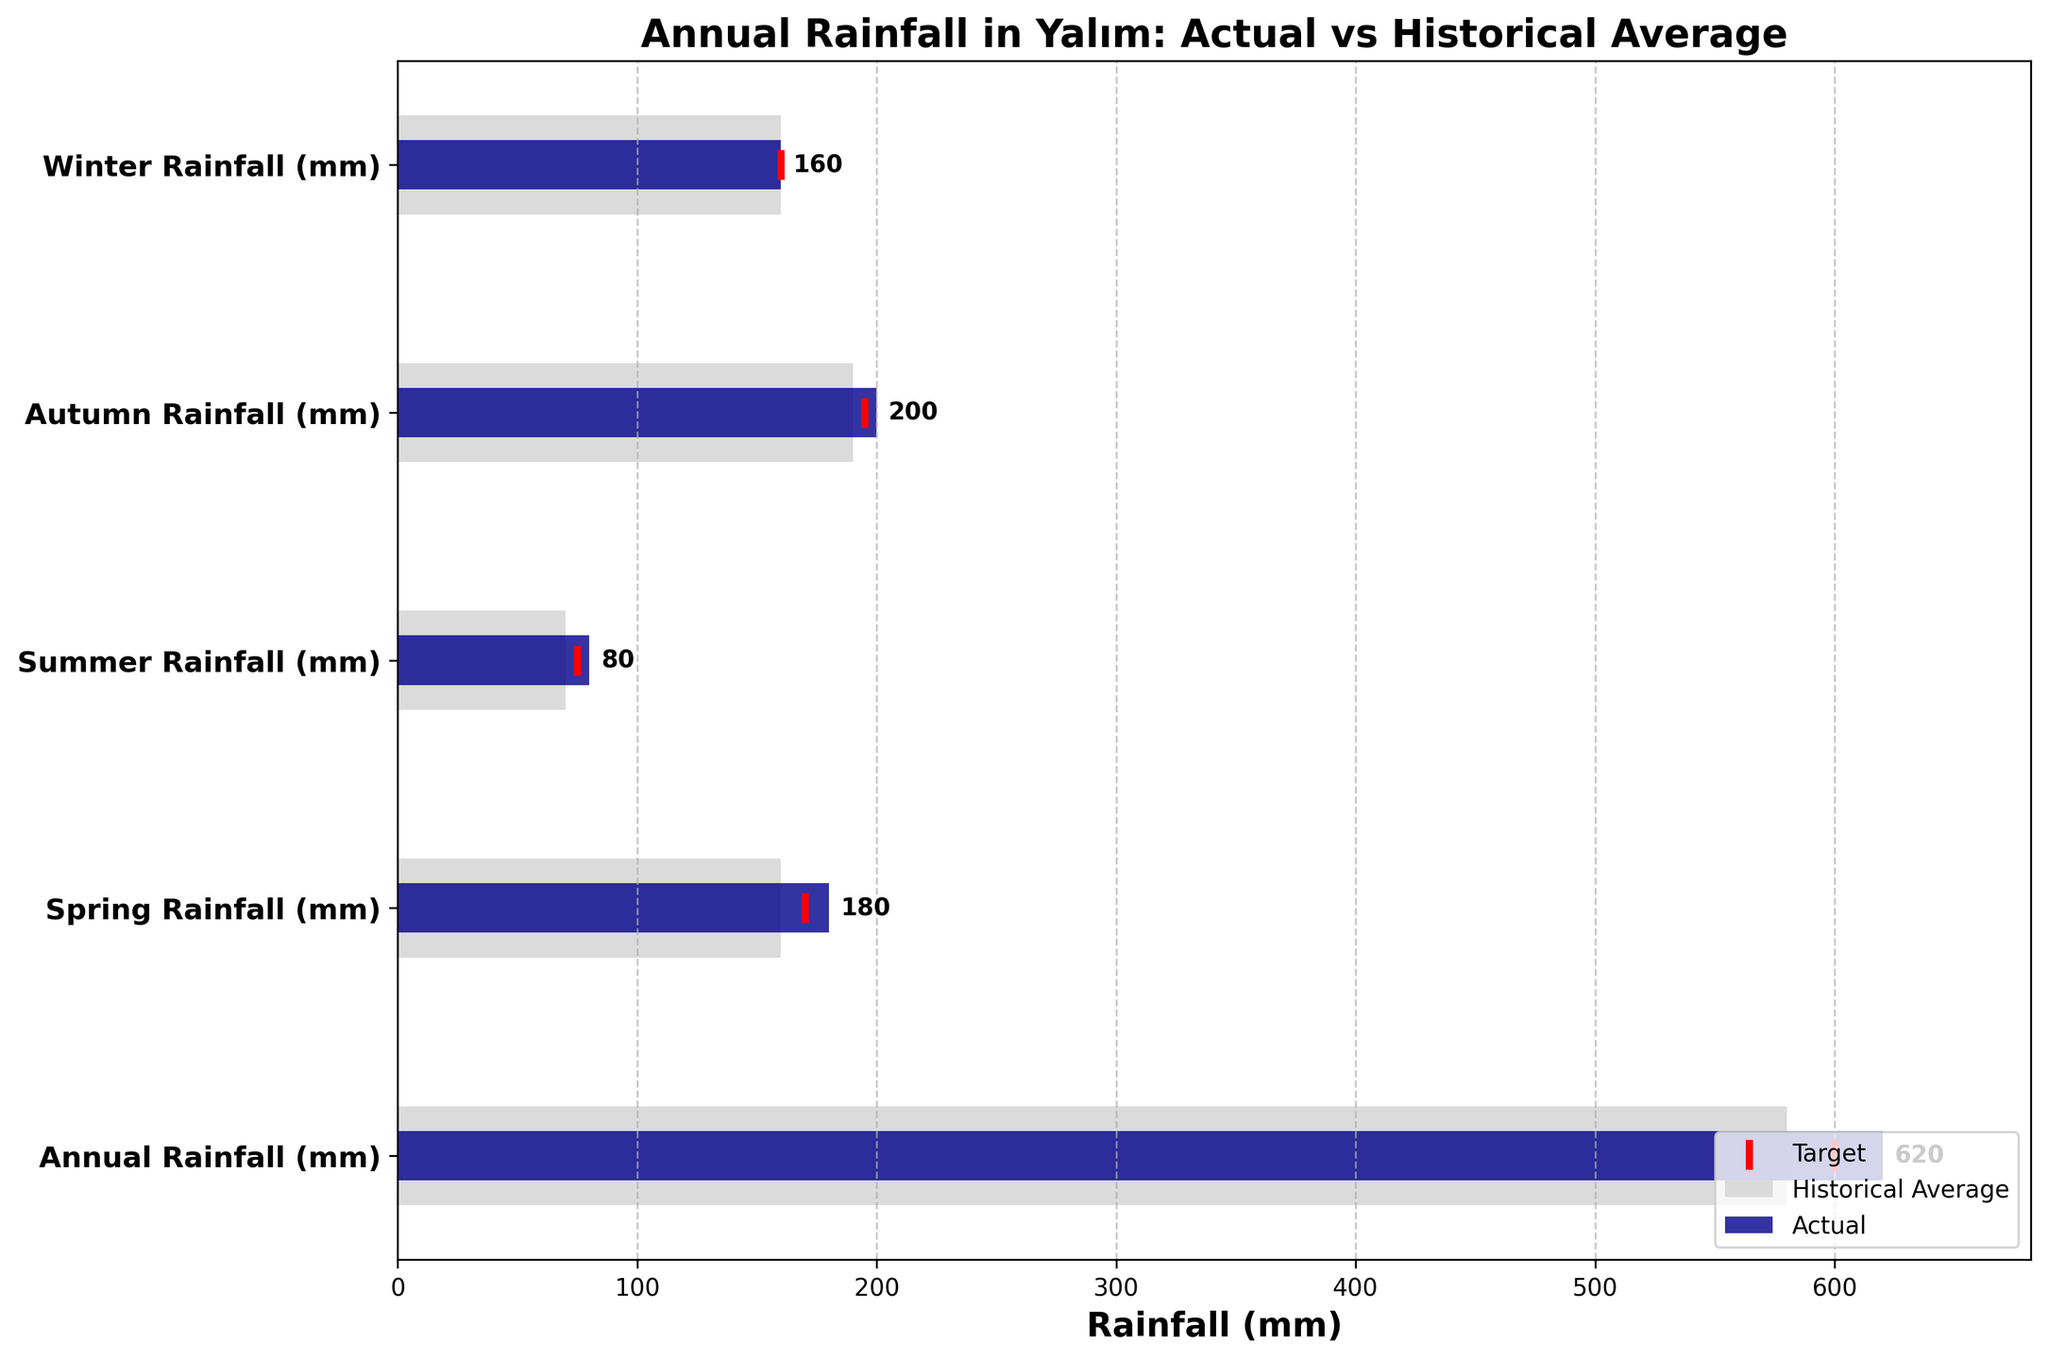How much is the actual annual rainfall in Yalım? The figure presents various rainfall measurements with labels for Actual, Historical Average, and Target. Focus on the first bar, which corresponds to "Annual Rainfall (mm)". The Actual annual rainfall is marked and labeled directly on the bar.
Answer: 620 mm How does the actual annual rainfall compare to the historical average? Compare the actual rainfall bar with the historical average bar for the "Annual Rainfall (mm)" category. The actual rainfall bar is taller than the historical average, indicating that the actual annual rainfall is higher than the historical average.
Answer: Actual rainfall is 40 mm higher than the historical average Did the winter rainfall meet the target value? Check the "Winter Rainfall (mm)" bar and locate the target marker, which is a red line. Compare it with the height of the actual rainfall bar. Both are at the same level, indicating that the actual winter rainfall met the target value.
Answer: Yes Which season had the highest actual rainfall? Focus on the "Actual" bars for each season: Spring, Summer, Autumn, and Winter. Compare their lengths. The longest bar represents the highest actual rainfall.
Answer: Autumn What is the difference between the historical average and the actual spring rainfall? Look at the "Spring Rainfall (mm)" category. Subtract the historical average (represented by the full bar) from the actual rainfall (the half-height bar).
Answer: 20 mm Which season's actual rainfall was closest to its historical average? Compare the length of each season's actual rainfall bar to its respective historical average bar. The bars that are closest in length represent the season with the closest measurements.
Answer: Winter How did the actual summer rainfall compare to the target? Check the "Summer Rainfall (mm)" category. Compare the length of the actual rainfall bar with the position of the red target marker. The actual bar is slightly higher than the marker.
Answer: The actual rainfall was 5 mm higher than the target Overall, did Yalım receive more or less rainfall than the target for the year? Observe the "Annual Rainfall (mm)" category. Compare the actual rainfall bar with the red target marker. The actual rainfall bar surpasses the marker.
Answer: More Which category shows the least difference between the actual rainfall and the historical average? Compare the differences for each category. The smaller the difference in bar lengths, the closer the values.
Answer: Winter What can be inferred about rainfall trends in Yalım based on this figure? Analyze the overall pattern comparing actual rainfall with historical averages and targets across different categories. Most actual values are higher than historical averages, suggesting a potential increase in rainfall over recent times.
Answer: Actual rainfall tends to be higher than historical averages 